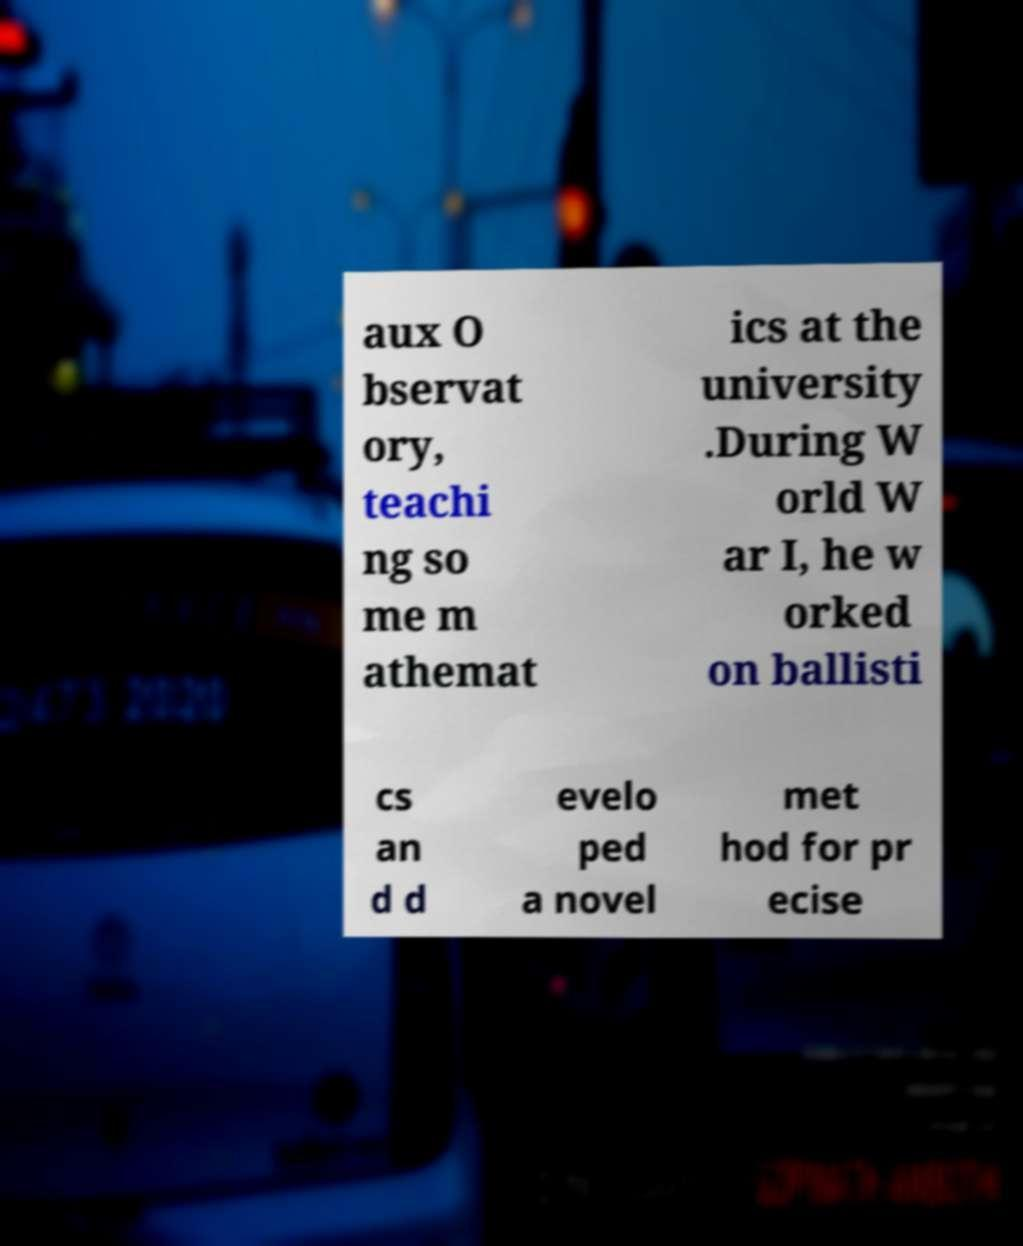What messages or text are displayed in this image? I need them in a readable, typed format. aux O bservat ory, teachi ng so me m athemat ics at the university .During W orld W ar I, he w orked on ballisti cs an d d evelo ped a novel met hod for pr ecise 